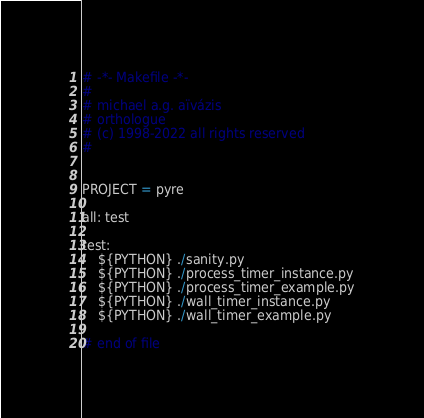<code> <loc_0><loc_0><loc_500><loc_500><_ObjectiveC_># -*- Makefile -*-
#
# michael a.g. aïvázis
# orthologue
# (c) 1998-2022 all rights reserved
#


PROJECT = pyre

all: test

test:
	${PYTHON} ./sanity.py
	${PYTHON} ./process_timer_instance.py
	${PYTHON} ./process_timer_example.py
	${PYTHON} ./wall_timer_instance.py
	${PYTHON} ./wall_timer_example.py

# end of file
</code> 